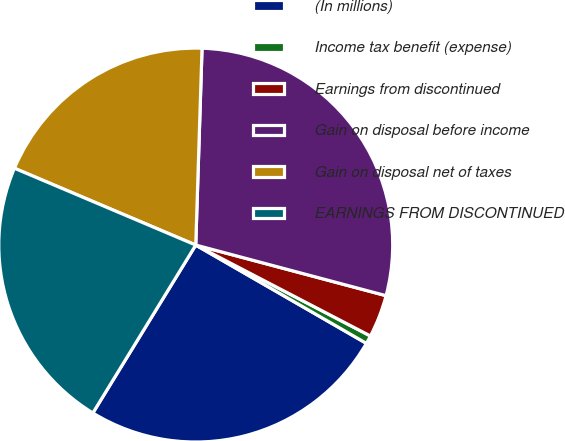<chart> <loc_0><loc_0><loc_500><loc_500><pie_chart><fcel>(In millions)<fcel>Income tax benefit (expense)<fcel>Earnings from discontinued<fcel>Gain on disposal before income<fcel>Gain on disposal net of taxes<fcel>EARNINGS FROM DISCONTINUED<nl><fcel>25.43%<fcel>0.68%<fcel>3.5%<fcel>28.63%<fcel>19.13%<fcel>22.63%<nl></chart> 